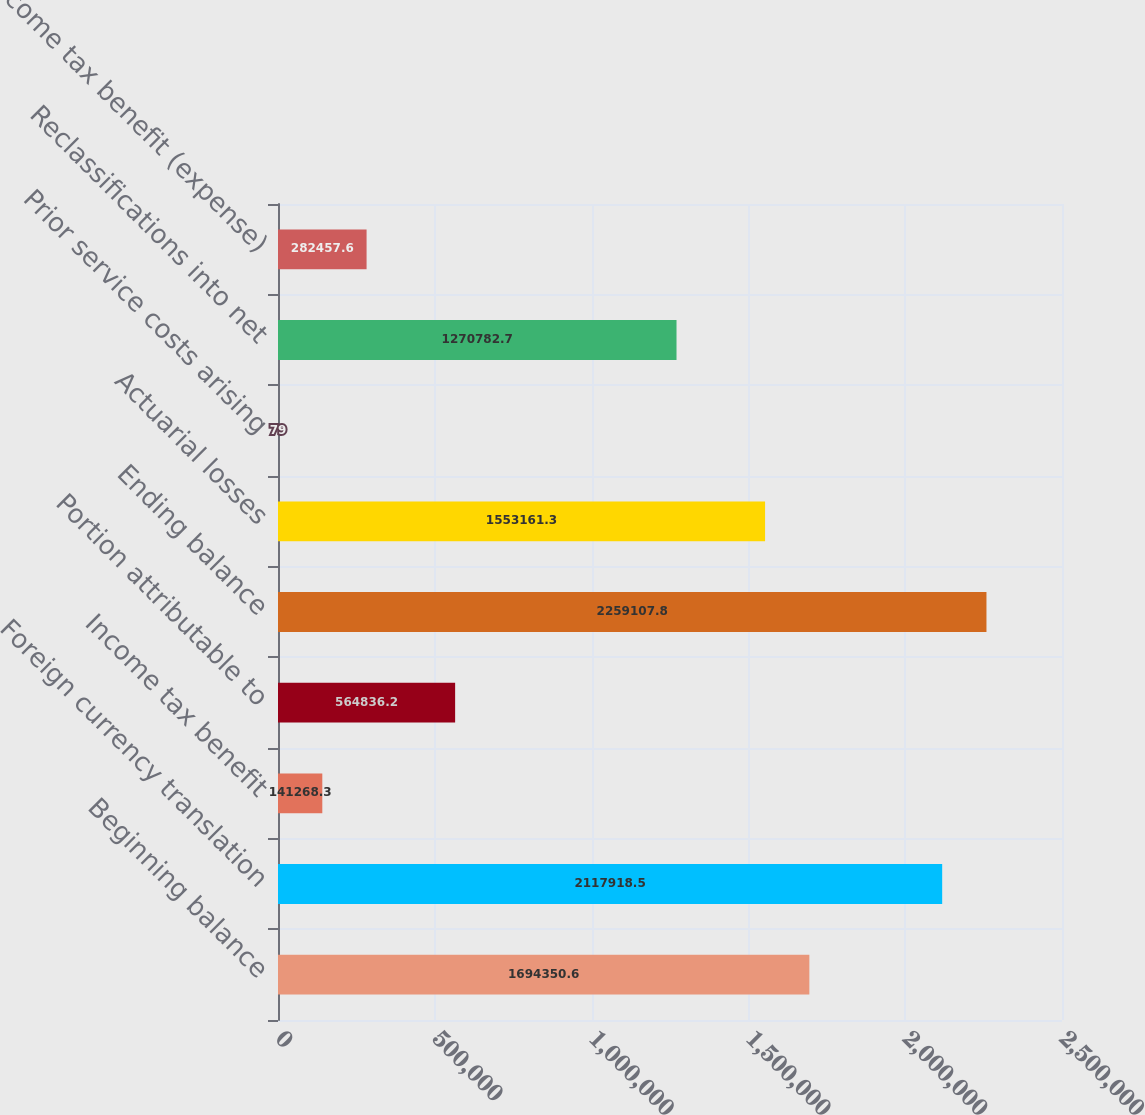Convert chart to OTSL. <chart><loc_0><loc_0><loc_500><loc_500><bar_chart><fcel>Beginning balance<fcel>Foreign currency translation<fcel>Income tax benefit<fcel>Portion attributable to<fcel>Ending balance<fcel>Actuarial losses<fcel>Prior service costs arising<fcel>Reclassifications into net<fcel>Income tax benefit (expense)<nl><fcel>1.69435e+06<fcel>2.11792e+06<fcel>141268<fcel>564836<fcel>2.25911e+06<fcel>1.55316e+06<fcel>79<fcel>1.27078e+06<fcel>282458<nl></chart> 